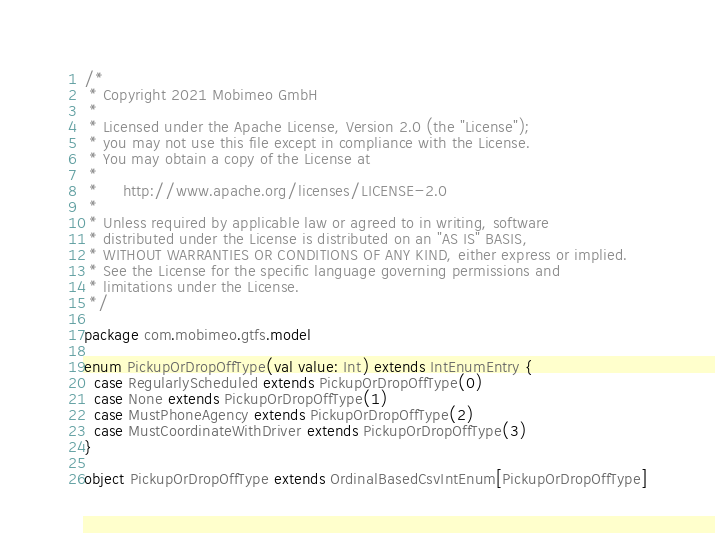<code> <loc_0><loc_0><loc_500><loc_500><_Scala_>/*
 * Copyright 2021 Mobimeo GmbH
 *
 * Licensed under the Apache License, Version 2.0 (the "License");
 * you may not use this file except in compliance with the License.
 * You may obtain a copy of the License at
 *
 *     http://www.apache.org/licenses/LICENSE-2.0
 *
 * Unless required by applicable law or agreed to in writing, software
 * distributed under the License is distributed on an "AS IS" BASIS,
 * WITHOUT WARRANTIES OR CONDITIONS OF ANY KIND, either express or implied.
 * See the License for the specific language governing permissions and
 * limitations under the License.
 */

package com.mobimeo.gtfs.model

enum PickupOrDropOffType(val value: Int) extends IntEnumEntry {
  case RegularlyScheduled extends PickupOrDropOffType(0)
  case None extends PickupOrDropOffType(1)
  case MustPhoneAgency extends PickupOrDropOffType(2)
  case MustCoordinateWithDriver extends PickupOrDropOffType(3)
}

object PickupOrDropOffType extends OrdinalBasedCsvIntEnum[PickupOrDropOffType]
</code> 